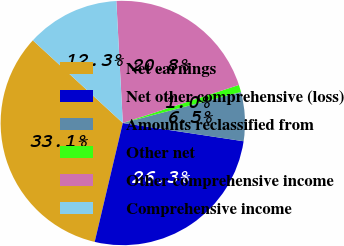<chart> <loc_0><loc_0><loc_500><loc_500><pie_chart><fcel>Net earnings<fcel>Net other comprehensive (loss)<fcel>Amounts reclassified from<fcel>Other net<fcel>Other comprehensive income<fcel>Comprehensive income<nl><fcel>33.13%<fcel>26.31%<fcel>6.47%<fcel>0.96%<fcel>20.8%<fcel>12.33%<nl></chart> 